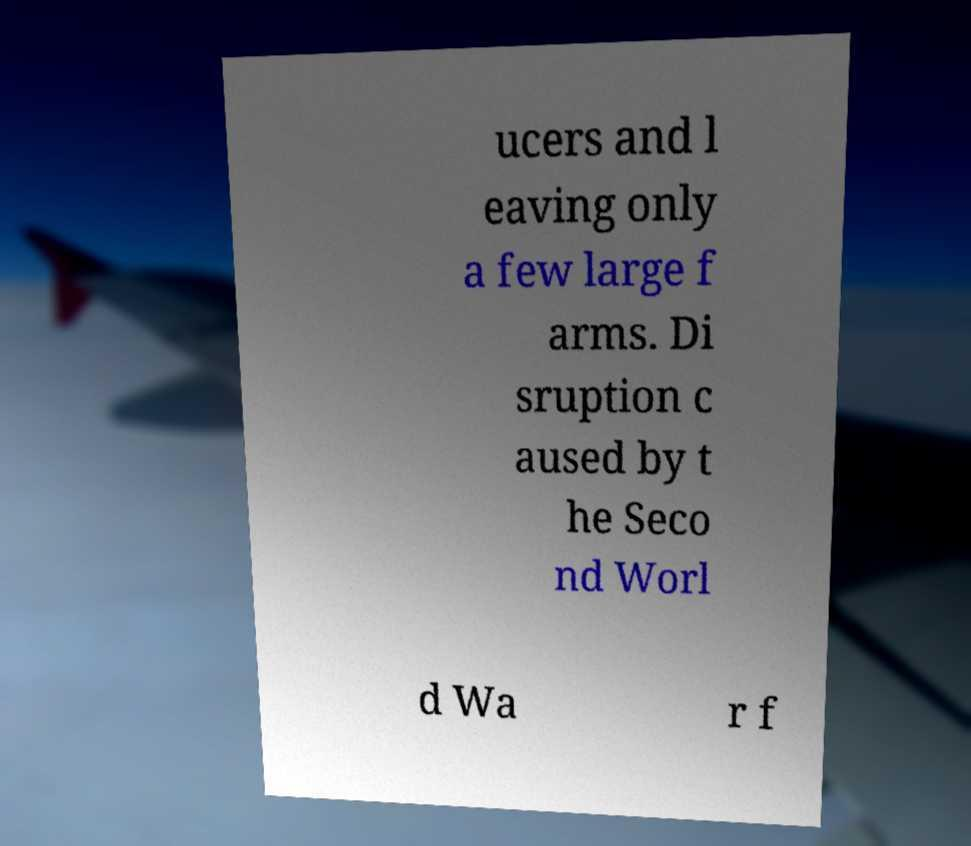Please identify and transcribe the text found in this image. ucers and l eaving only a few large f arms. Di sruption c aused by t he Seco nd Worl d Wa r f 